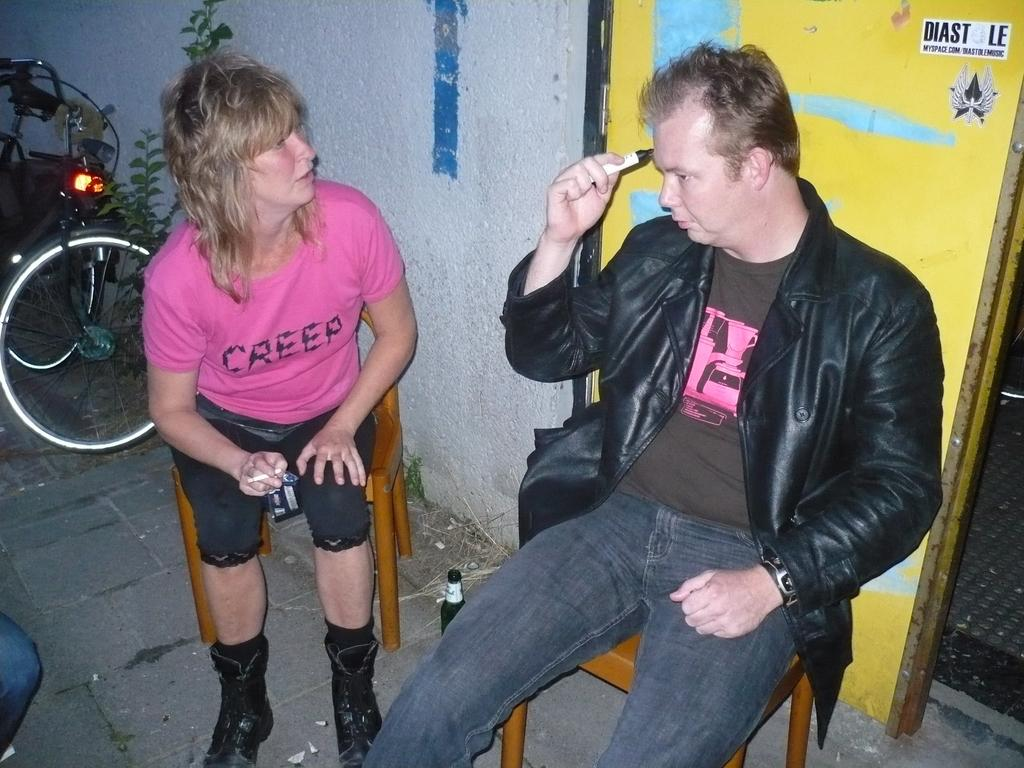How many people are in the image? There are two people in the image, a man and a woman. What are the man and woman doing in the image? Both the man and woman are sitting on chairs. What other object can be seen in the image? There is a bicycle in the image. What is visible in the background of the image? There is a wall in the background of the image. Can you hear the woman laughing in the image? There is no sound in the image, so it is not possible to hear the woman laughing. How many oranges are on the bicycle in the image? There are no oranges present in the image; it features a man, a woman, chairs, and a bicycle. 